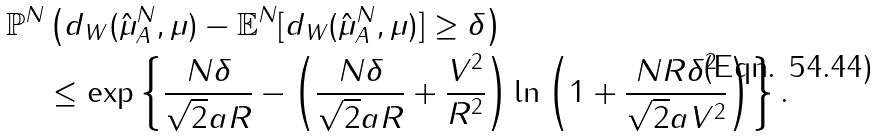Convert formula to latex. <formula><loc_0><loc_0><loc_500><loc_500>\mathbb { P } ^ { N } & \left ( d _ { W } ( \hat { \mu } _ { A } ^ { N } , \mu ) - \mathbb { E } ^ { N } [ d _ { W } ( \hat { \mu } _ { A } ^ { N } , \mu ) ] \geq \delta \right ) \\ & \leq \exp \left \{ \frac { N \delta } { \sqrt { 2 } a R } - \left ( \frac { N \delta } { \sqrt { 2 } a R } + \frac { V ^ { 2 } } { R ^ { 2 } } \right ) \ln \left ( 1 + \frac { N R \delta ^ { 2 } } { \sqrt { 2 } a V ^ { 2 } } \right ) \right \} .</formula> 